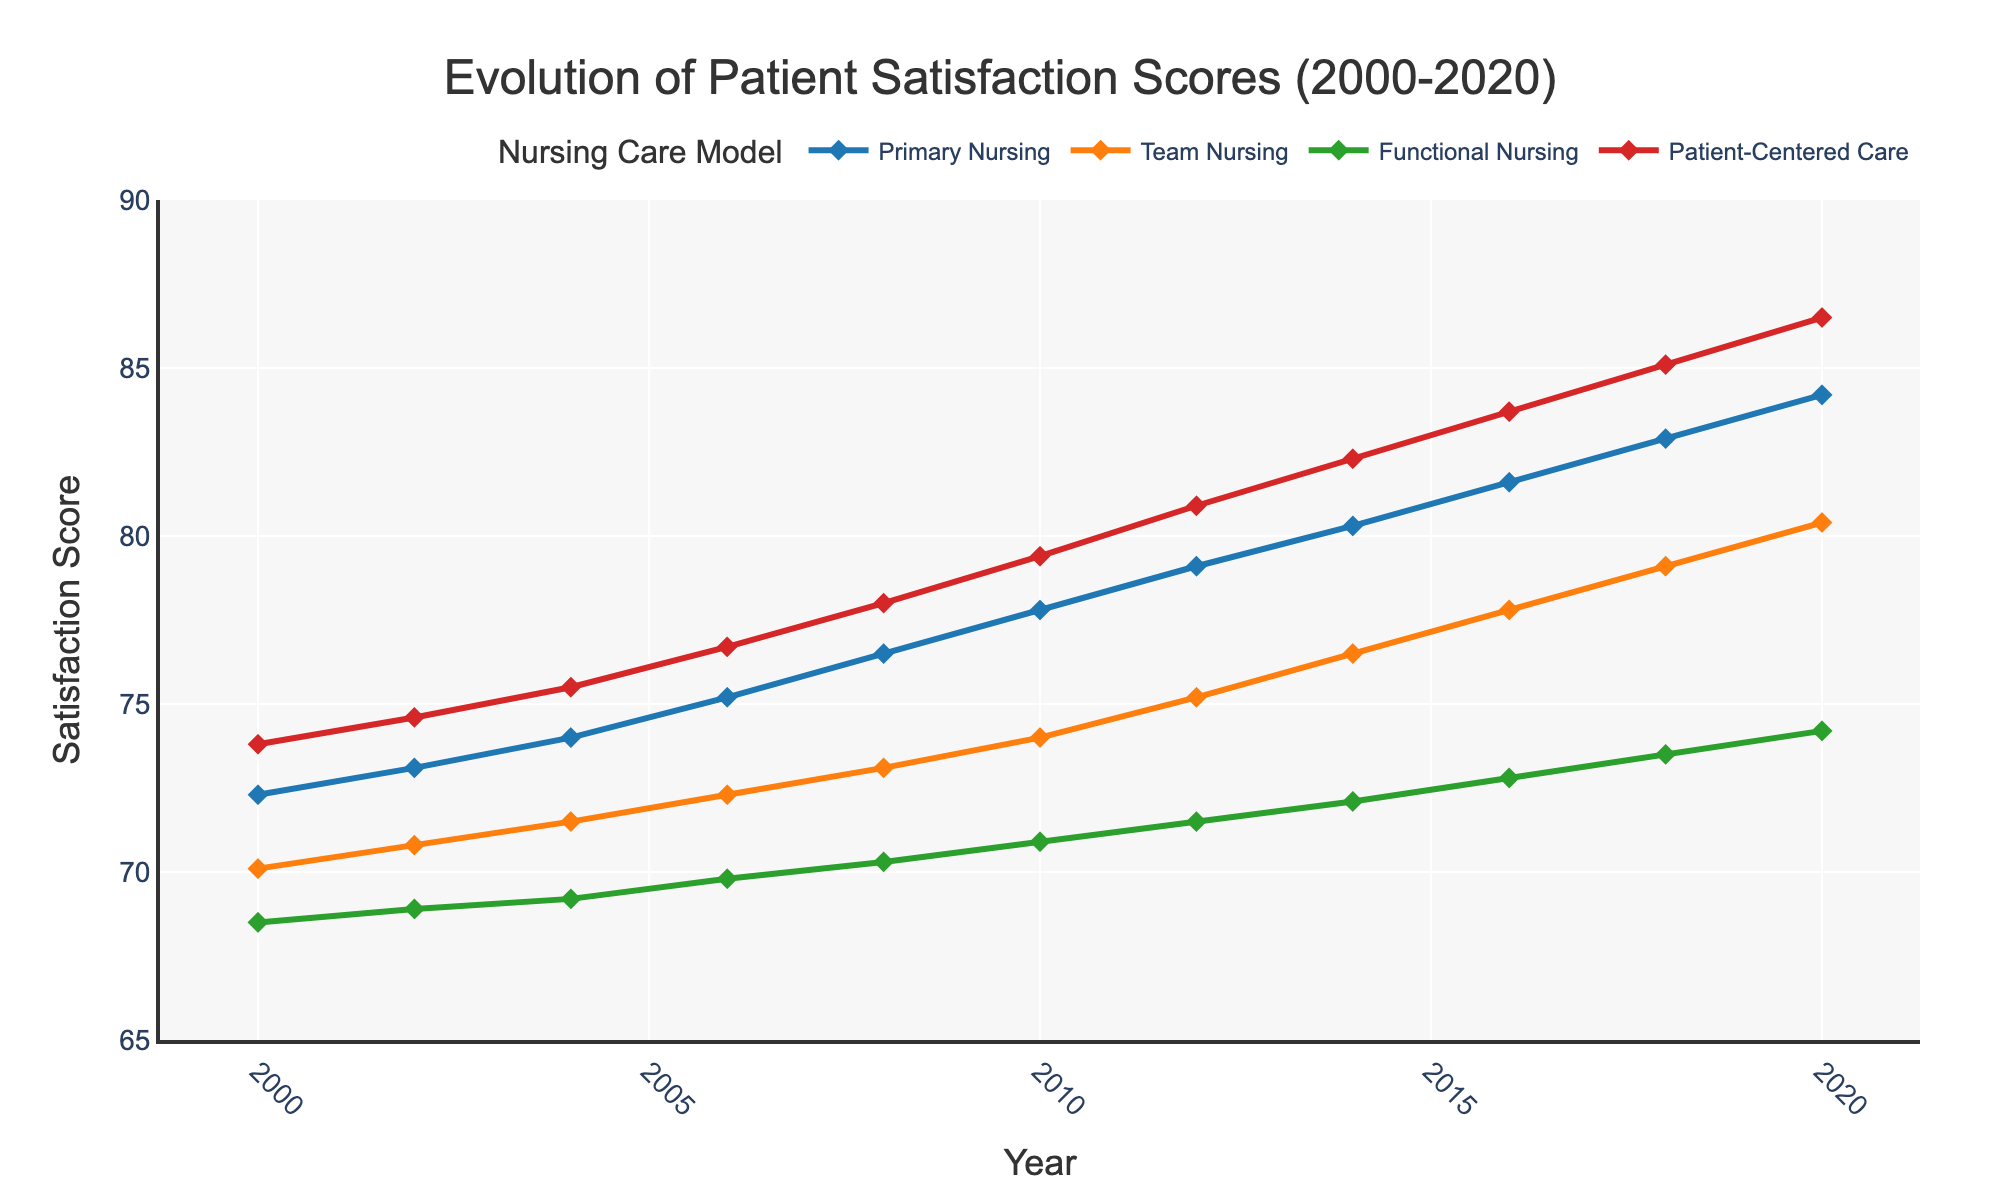What trends are observed in patient satisfaction scores for Primary Nursing from 2000 to 2020? The satisfaction scores for Primary Nursing show a consistent increase from 72.3 in 2000 to 84.2 in 2020. This indicates a positive trend.
Answer: Increasing trend How does the patient satisfaction score of Team Nursing in 2020 compare to its score in 2000? The satisfaction score for Team Nursing was 70.1 in 2000 and increased to 80.4 in 2020. This shows a positive difference of 10.3 points over the 20-year period.
Answer: 80.4 is greater than 70.1 Which nursing care model shows the highest patient satisfaction score in 2014? The patient-centered care model has the highest score of 82.3 in 2014 compared to the other models.
Answer: Patient-Centered Care By how much did the patient satisfaction score for Functional Nursing increase between 2006 and 2016? The score for Functional Nursing in 2006 was 69.8, and it increased to 72.8 in 2016. The difference is 72.8 - 69.8 = 3.
Answer: 3 points Which nursing care model had the least improvement in patient satisfaction scores from 2000 to 2020? Functional Nursing had the least improvement, moving from 68.5 in 2000 to 74.2 in 2020, a 5.7 point increase.
Answer: Functional Nursing In 2018, which two nursing care models had the smallest difference in satisfaction scores? In 2018, the satisfaction scores were 82.9 for Primary Nursing and 79.1 for Team Nursing. The difference is 82.9 - 79.1 = 3.8. This is the smallest difference compared to other model pairs.
Answer: Primary Nursing and Team Nursing What is the cumulative score of patient satisfaction for Patient-Centered Care from 2000 to 2010? Adding up the scores for Patient-Centered Care from 2000 to 2010: 73.8 + 74.6 + 75.5 + 76.7 + 78.0 + 79.4 = 458.
Answer: 458 Which year shows the highest difference in patient satisfaction scores between Primary Nursing and Functional Nursing? The year 2020 shows the highest difference where Primary Nursing is 84.2 and Functional Nursing is 74.2. The difference is 84.2 - 74.2 = 10.
Answer: 2020 How does the trend of patient satisfaction in Patient-Centered Care compare to the trend in Primary Nursing? Both trends show a consistent increase over time from 2000 to 2020, but Patient-Centered Care consistently has higher scores than Primary Nursing throughout the period.
Answer: Similar increasing trends 